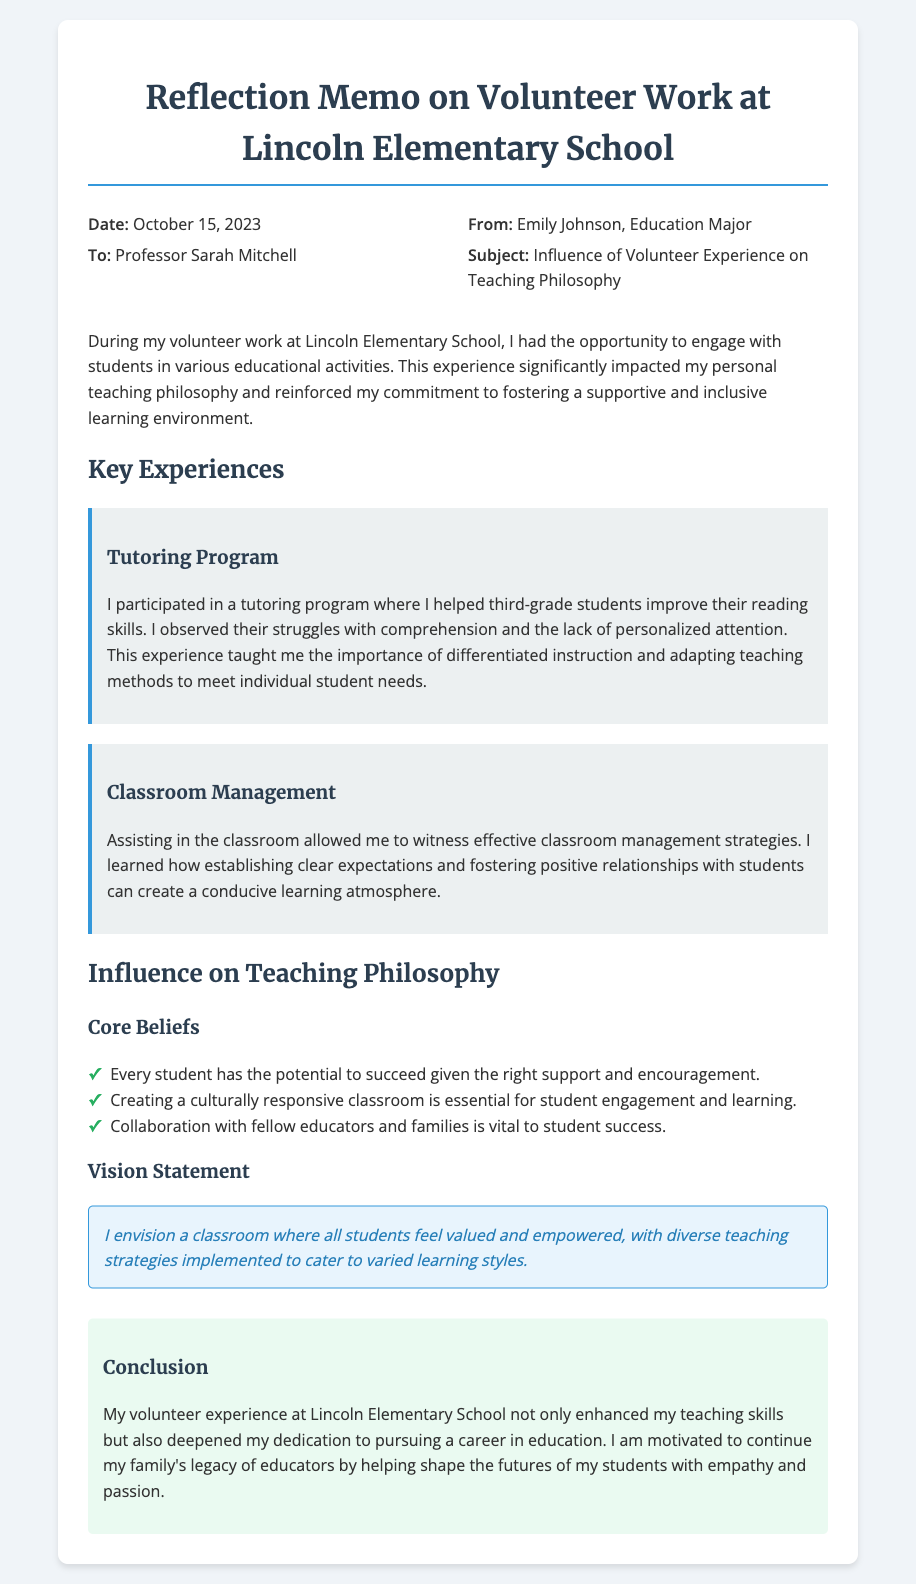What is the date of the memo? The date of the memo is explicitly stated in the header section.
Answer: October 15, 2023 Who is the recipient of the memo? The recipient of the memo is mentioned in the header section.
Answer: Professor Sarah Mitchell What is Emily Johnson's major? The major of Emily Johnson is mentioned in the introductory section of the document.
Answer: Education Major What was one of the key experiences mentioned? The key experiences section lists specific activities that Emily participated in during her volunteer work.
Answer: Tutoring Program What is one core belief stated in the memo? The core beliefs section lists several beliefs that guided Emily's philosophy.
Answer: Every student has the potential to succeed given the right support and encouragement In what type of classroom environment does Emily envision teaching? The vision statement describes the kind of classroom atmosphere Emily hopes to create.
Answer: A classroom where all students feel valued and empowered How did the volunteer experience influence Emily's career aspirations? The conclusion of the memo summarizes the impact of the volunteer work on her professional goals.
Answer: Enhanced her teaching skills and deepened her dedication to pursuing a career in education 